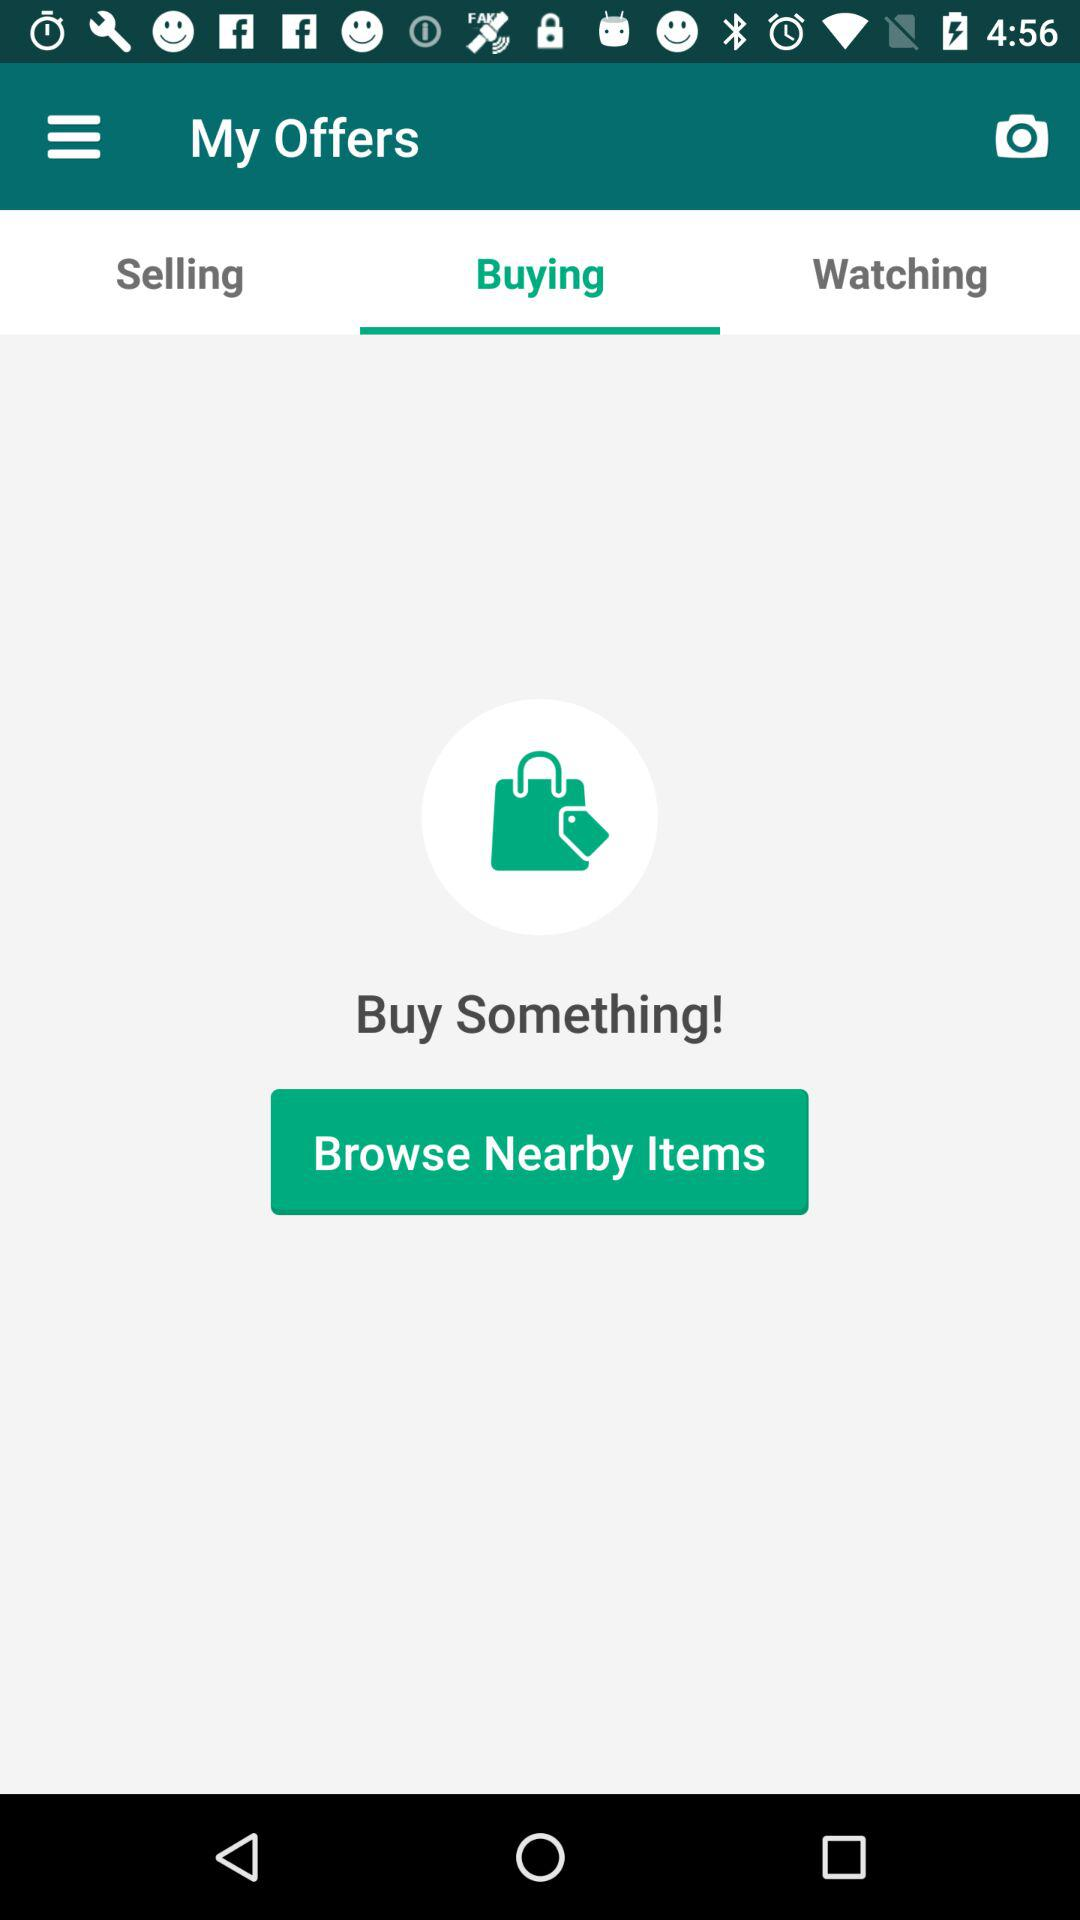Which tab is selected? The selected tab is "Buying". 